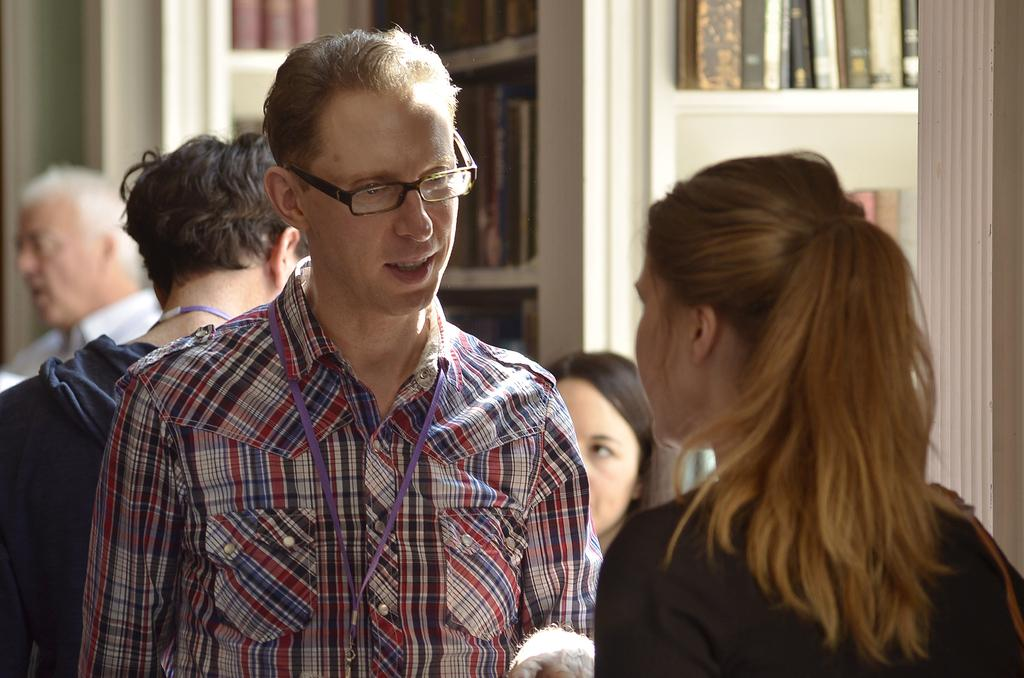Where was the image taken? The image was taken inside a room. Who or what can be seen in the image? There is a group of people in the image. What is visible in the background of the image? There is a shelf in the background of the image. What is on the shelf? There are books on the shelf. How many boats are visible in the image? There are no boats present in the image. What type of team is shown working together in the image? There is no team or any indication of teamwork in the image; it simply shows a group of people. 